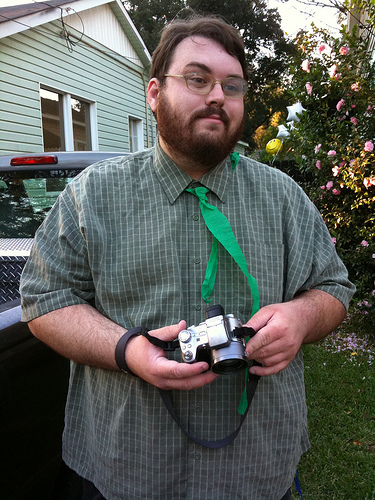He is in front of what? The man is standing in front of a pale green building, giving the impression of a residential house with its homely design. 